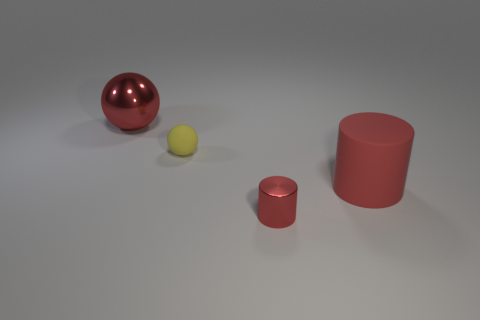Subtract all red balls. How many balls are left? 1 Add 1 blue metal balls. How many objects exist? 5 Subtract 2 spheres. How many spheres are left? 0 Subtract 0 yellow cylinders. How many objects are left? 4 Subtract all yellow cylinders. Subtract all red balls. How many cylinders are left? 2 Subtract all cyan spheres. How many yellow cylinders are left? 0 Subtract all spheres. Subtract all brown matte spheres. How many objects are left? 2 Add 4 red metal cylinders. How many red metal cylinders are left? 5 Add 4 large red objects. How many large red objects exist? 6 